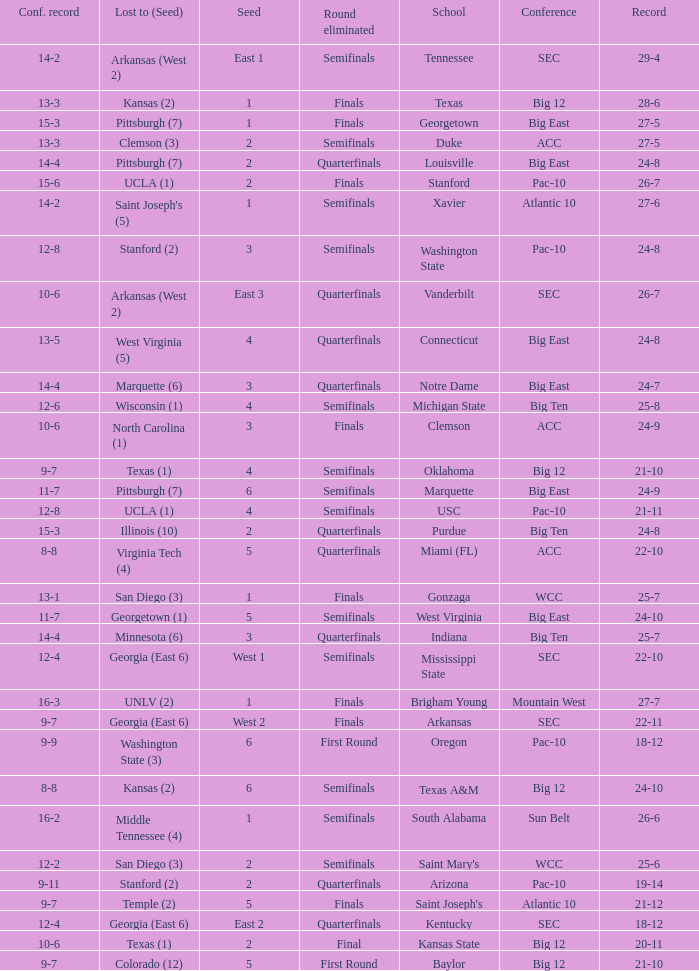Name the school where conference record is 12-6 Michigan State. 